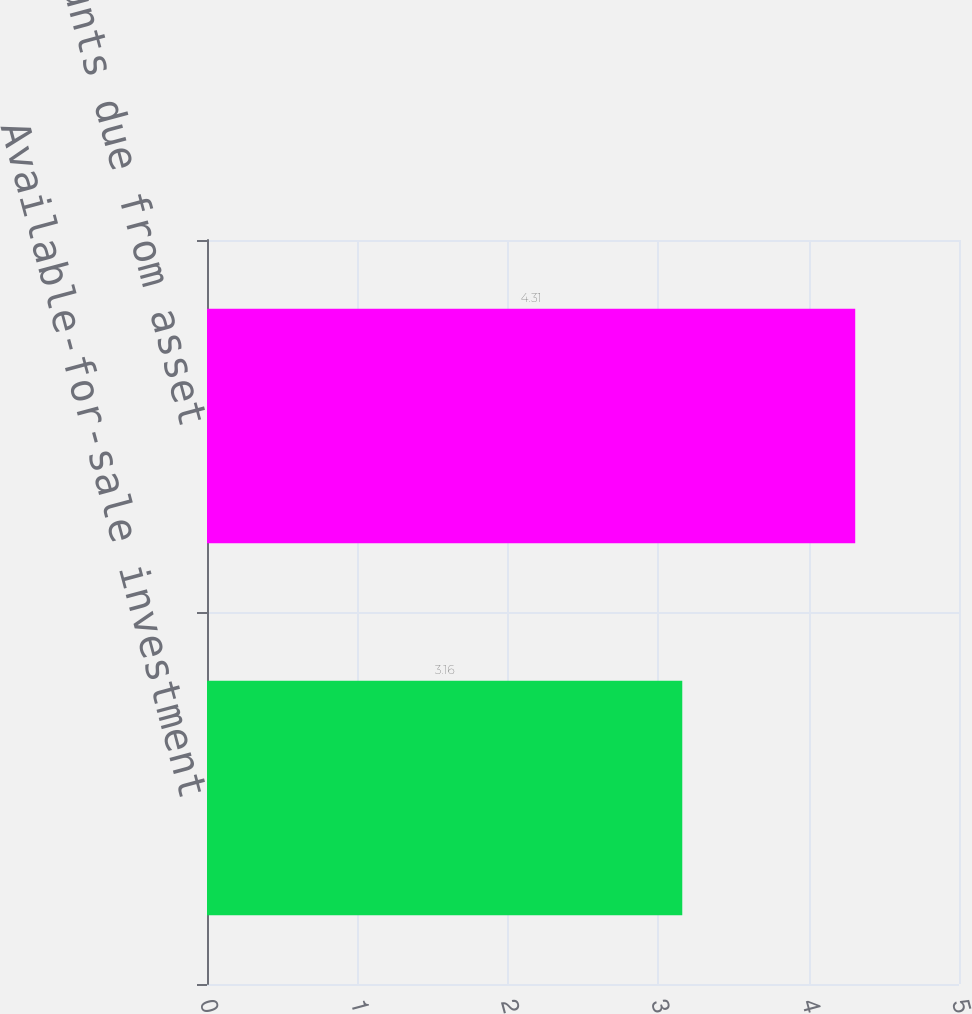Convert chart. <chart><loc_0><loc_0><loc_500><loc_500><bar_chart><fcel>Available-for-sale investment<fcel>Amounts due from asset<nl><fcel>3.16<fcel>4.31<nl></chart> 